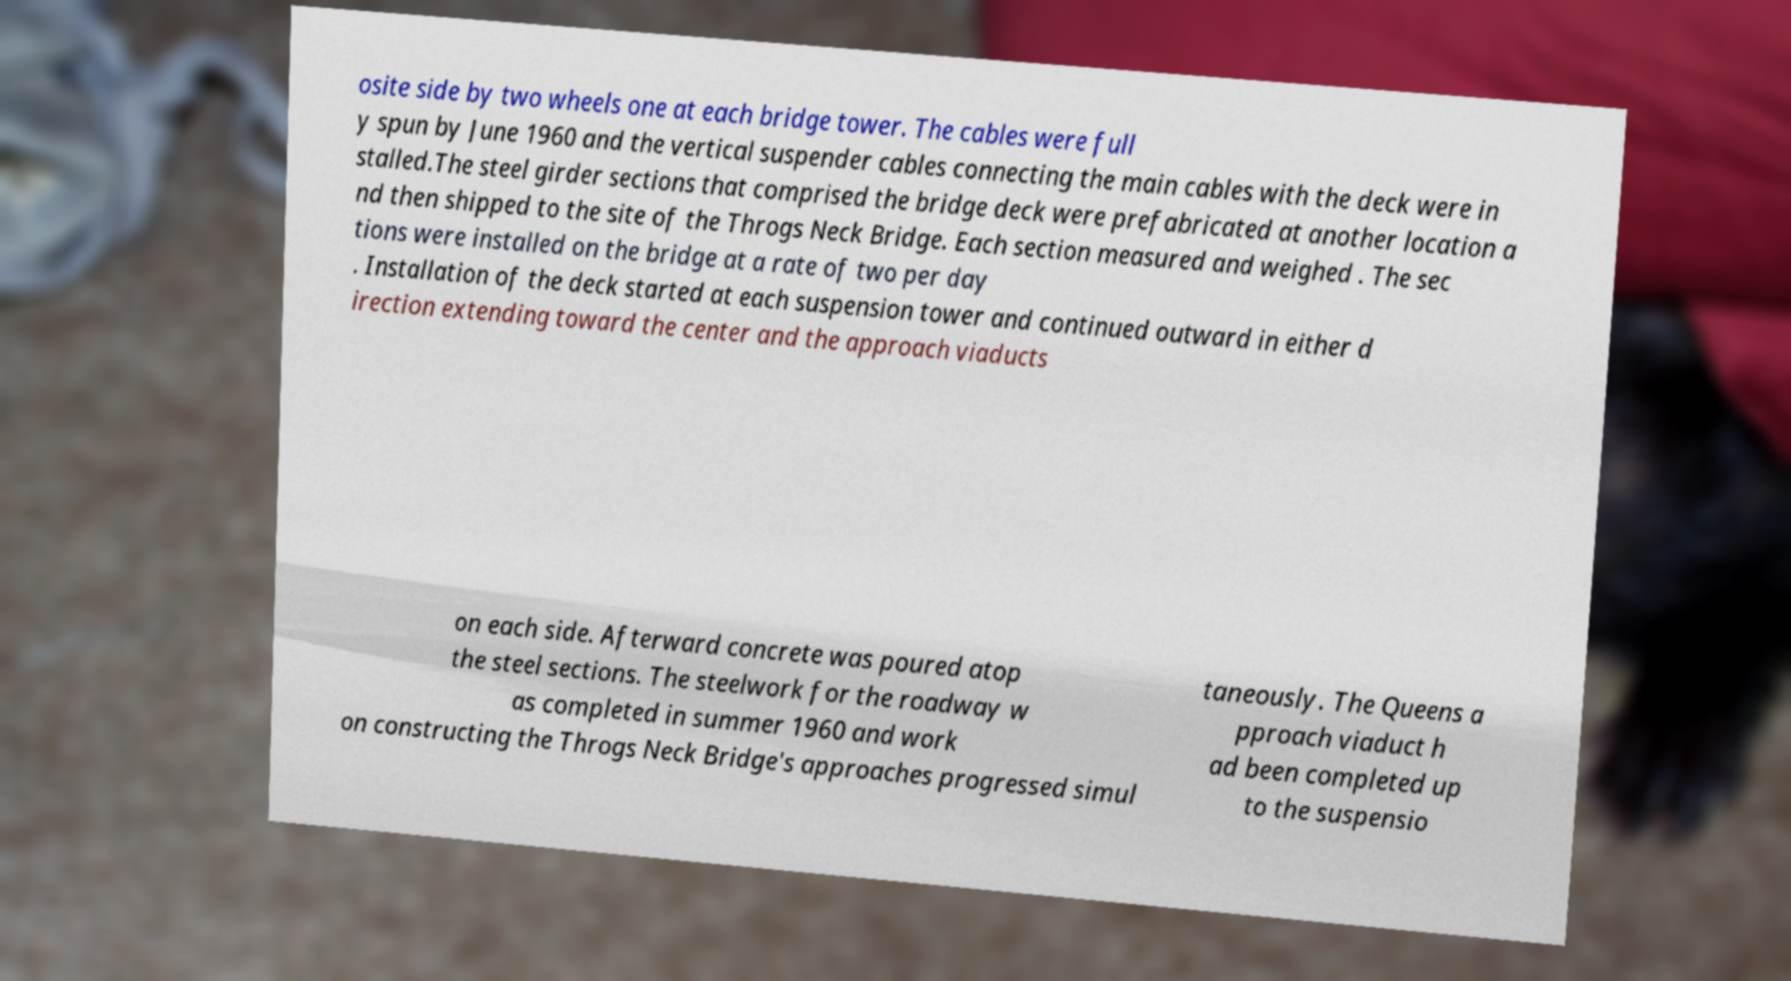Can you read and provide the text displayed in the image?This photo seems to have some interesting text. Can you extract and type it out for me? osite side by two wheels one at each bridge tower. The cables were full y spun by June 1960 and the vertical suspender cables connecting the main cables with the deck were in stalled.The steel girder sections that comprised the bridge deck were prefabricated at another location a nd then shipped to the site of the Throgs Neck Bridge. Each section measured and weighed . The sec tions were installed on the bridge at a rate of two per day . Installation of the deck started at each suspension tower and continued outward in either d irection extending toward the center and the approach viaducts on each side. Afterward concrete was poured atop the steel sections. The steelwork for the roadway w as completed in summer 1960 and work on constructing the Throgs Neck Bridge's approaches progressed simul taneously. The Queens a pproach viaduct h ad been completed up to the suspensio 